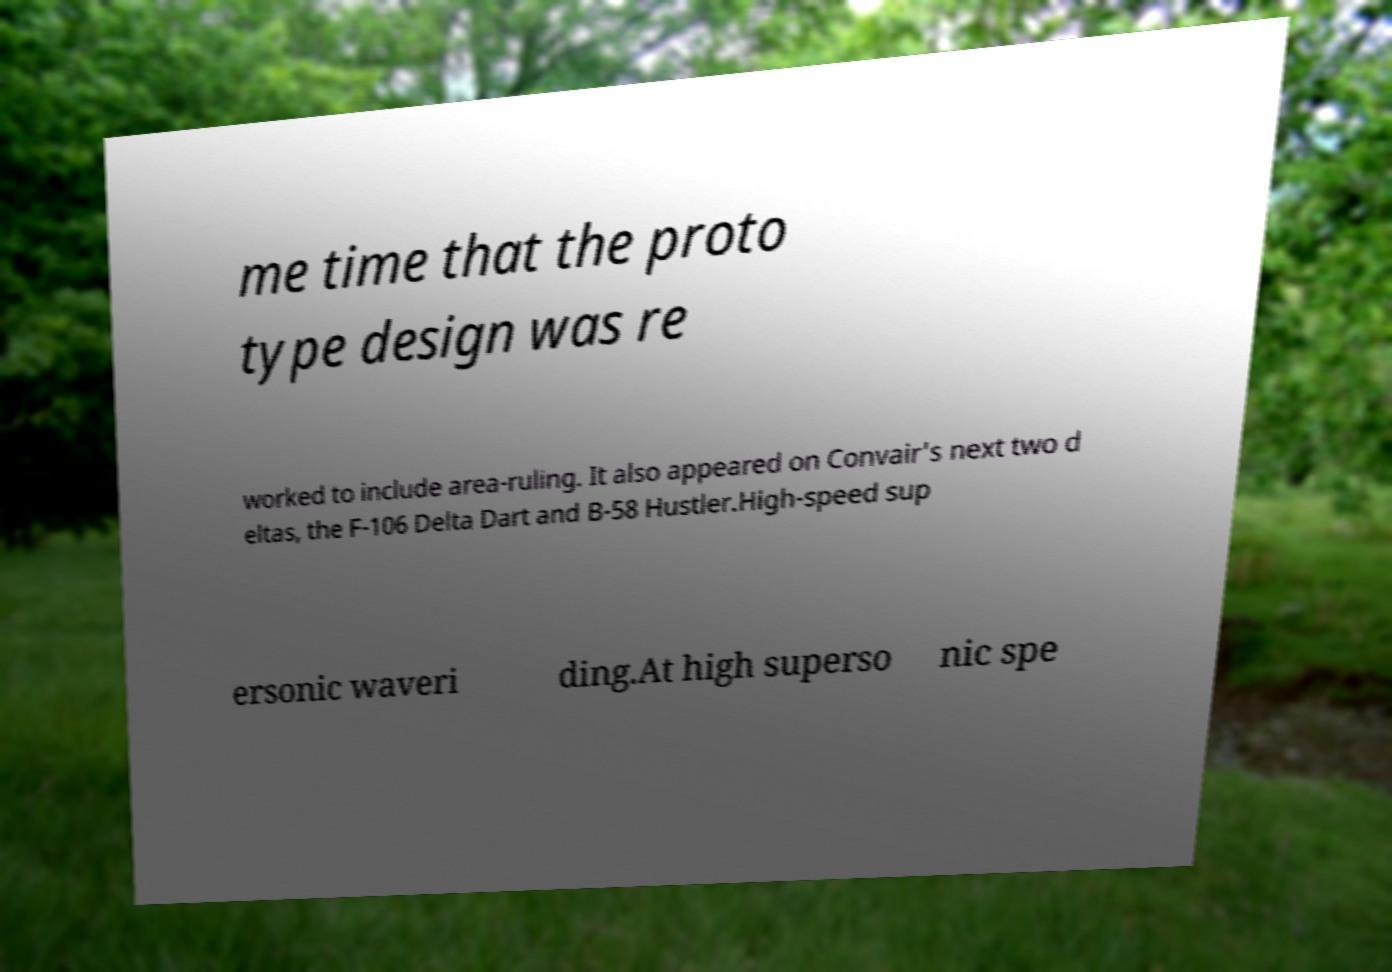Can you read and provide the text displayed in the image?This photo seems to have some interesting text. Can you extract and type it out for me? me time that the proto type design was re worked to include area-ruling. It also appeared on Convair's next two d eltas, the F-106 Delta Dart and B-58 Hustler.High-speed sup ersonic waveri ding.At high superso nic spe 